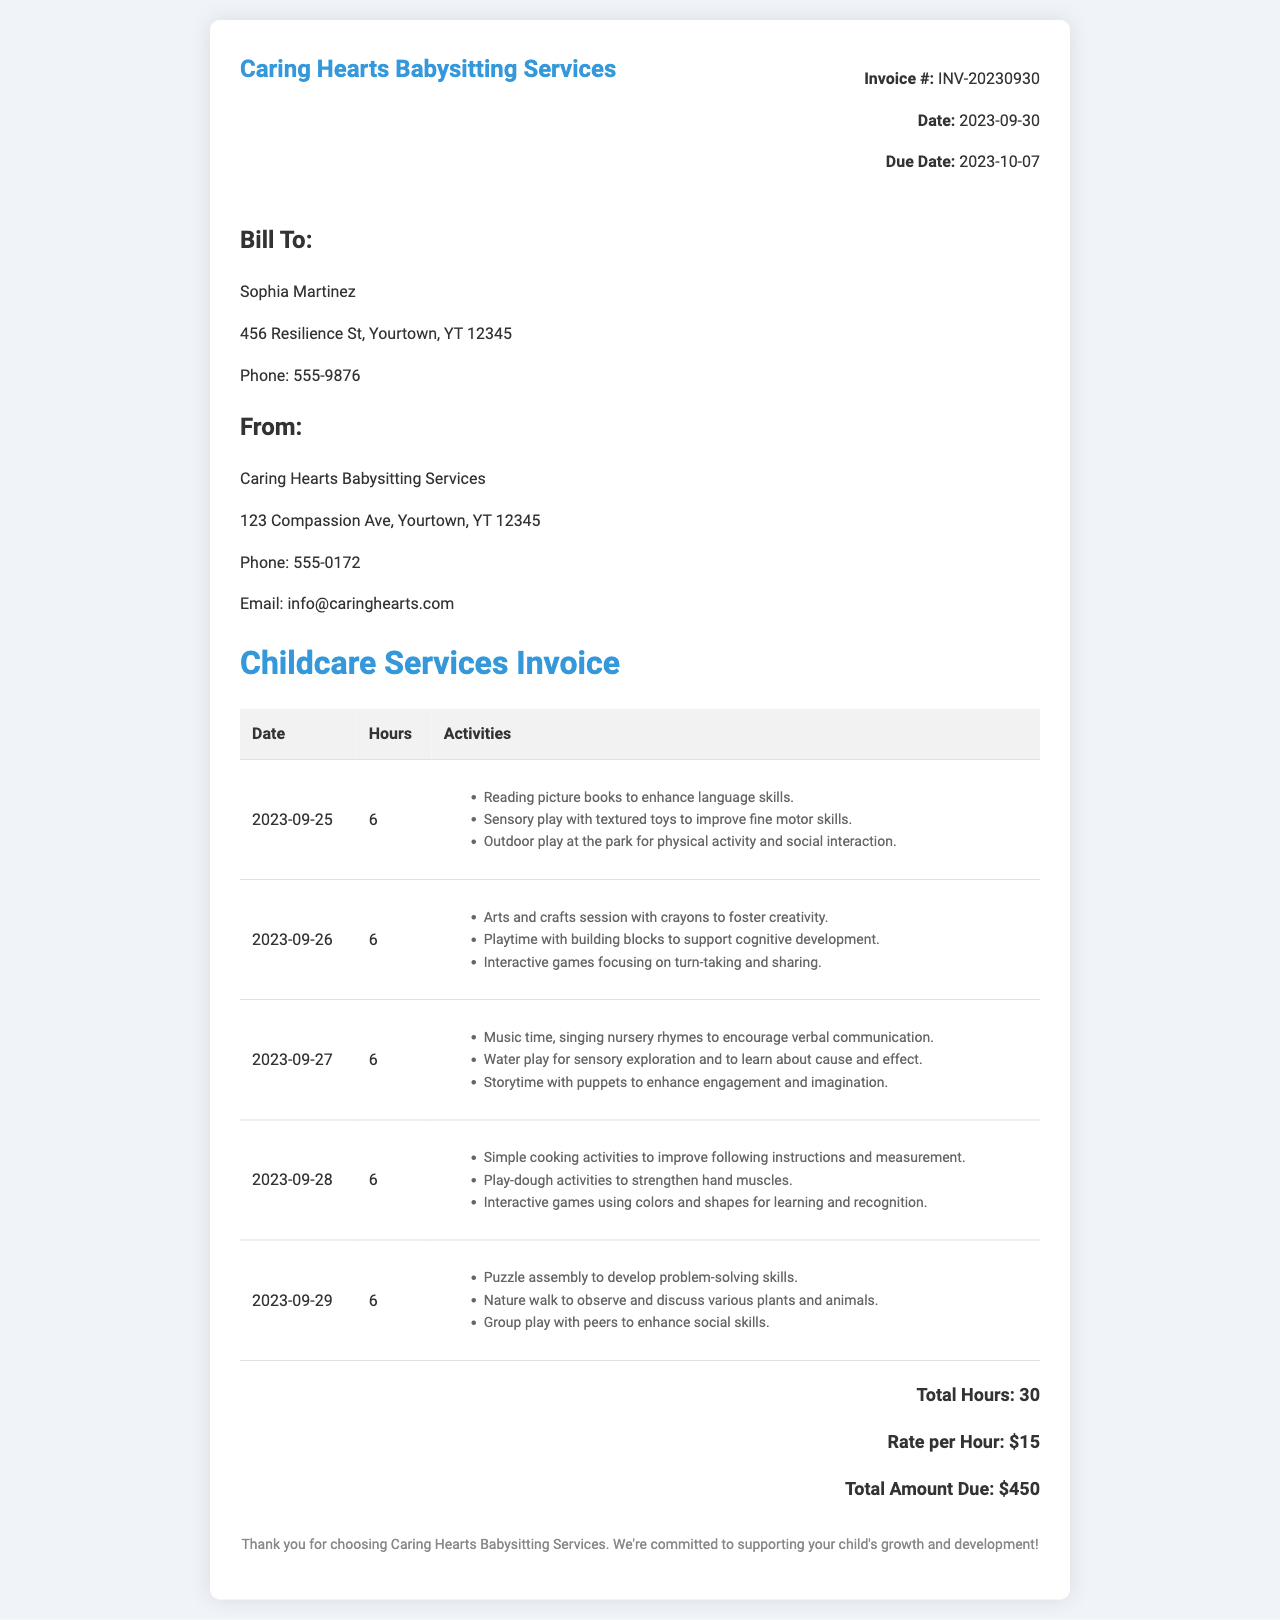What is the invoice number? The invoice number is found in the invoice details section, labeled as Invoice #:
Answer: INV-20230930 How many total hours of service were provided? The total hours of service can be found in the invoice summary, indicating the sum of hours worked.
Answer: 30 What is the rate per hour for the babysitting services? The rate per hour is listed in the total section of the invoice, providing the cost of each hour of service.
Answer: $15 What is the total amount due? The total amount due is calculated in the invoice and mentioned in the total section.
Answer: $450 Who is the client receiving this invoice? The client's name is located in the "Bill To" section of the invoice.
Answer: Sophia Martinez What significant activity was done on 2023-09-26? This is found within the activities listed for that date in the invoice.
Answer: Arts and crafts session with crayons to foster creativity How many days did the babysitting services cover? This is determined by counting the entries in the services table, each representing a day of service.
Answer: 5 What organization provided the childcare services? The name of the service provider is located in the "From" section of the invoice.
Answer: Caring Hearts Babysitting Services What was the reason for outdoor play at the park on 2023-09-25? This can be inferred from the activities listed for that date.
Answer: For physical activity and social interaction 